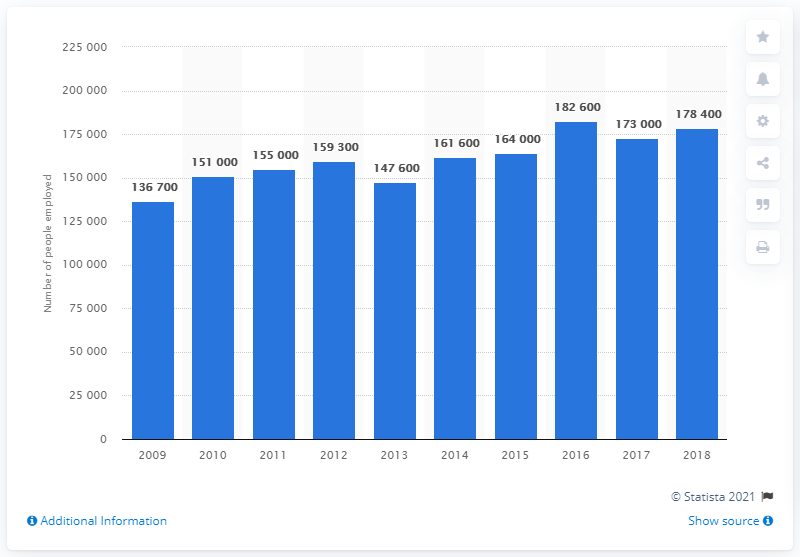Specify some key components in this picture. The City of London has employed individuals in the financial and insurance sector since 2009. In 2018, approximately 178,400 people were employed in the financial services sector in London. In 2016, there were approximately 182,600 people employed in the financial and insurance services sector. 